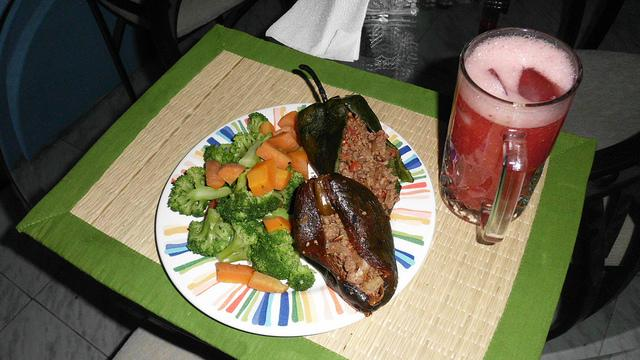What type of drink is in the cup? Please explain your reasoning. blended juice. Of the answers provided, only answer a matches the color visible in the cup. 